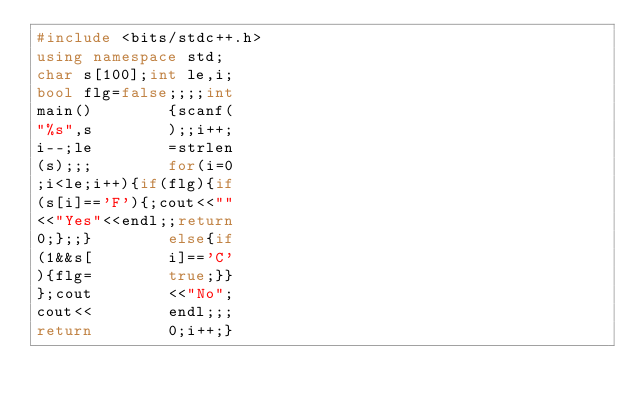<code> <loc_0><loc_0><loc_500><loc_500><_C++_>#include <bits/stdc++.h>
using namespace std;
char s[100];int le,i;
bool flg=false;;;;int
main()        {scanf(
"%s",s        );;i++;
i--;le        =strlen
(s);;;        for(i=0
;i<le;i++){if(flg){if
(s[i]=='F'){;cout<<""
<<"Yes"<<endl;;return
0;};;}        else{if
(1&&s[        i]=='C'
){flg=        true;}}
};cout        <<"No";
cout<<        endl;;;
return        0;i++;}
</code> 